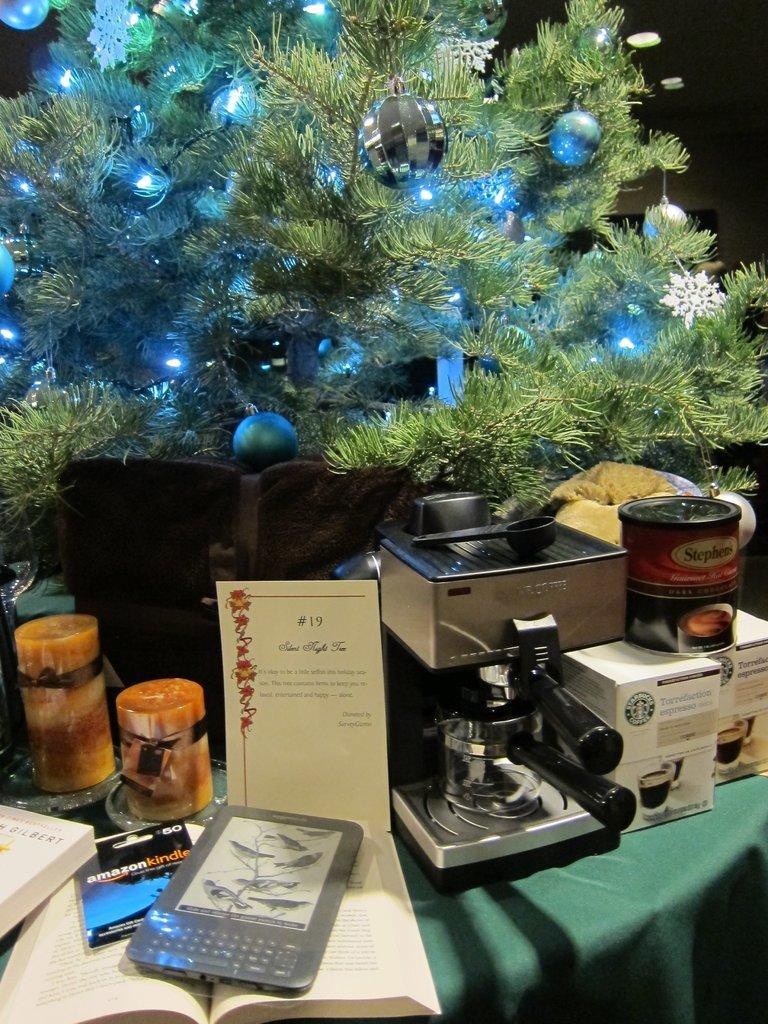Can you describe this image briefly? In this image there is a kindle, a book, two glass jars, a coffee machine on a table, behind the table there is a Christmas tree. 